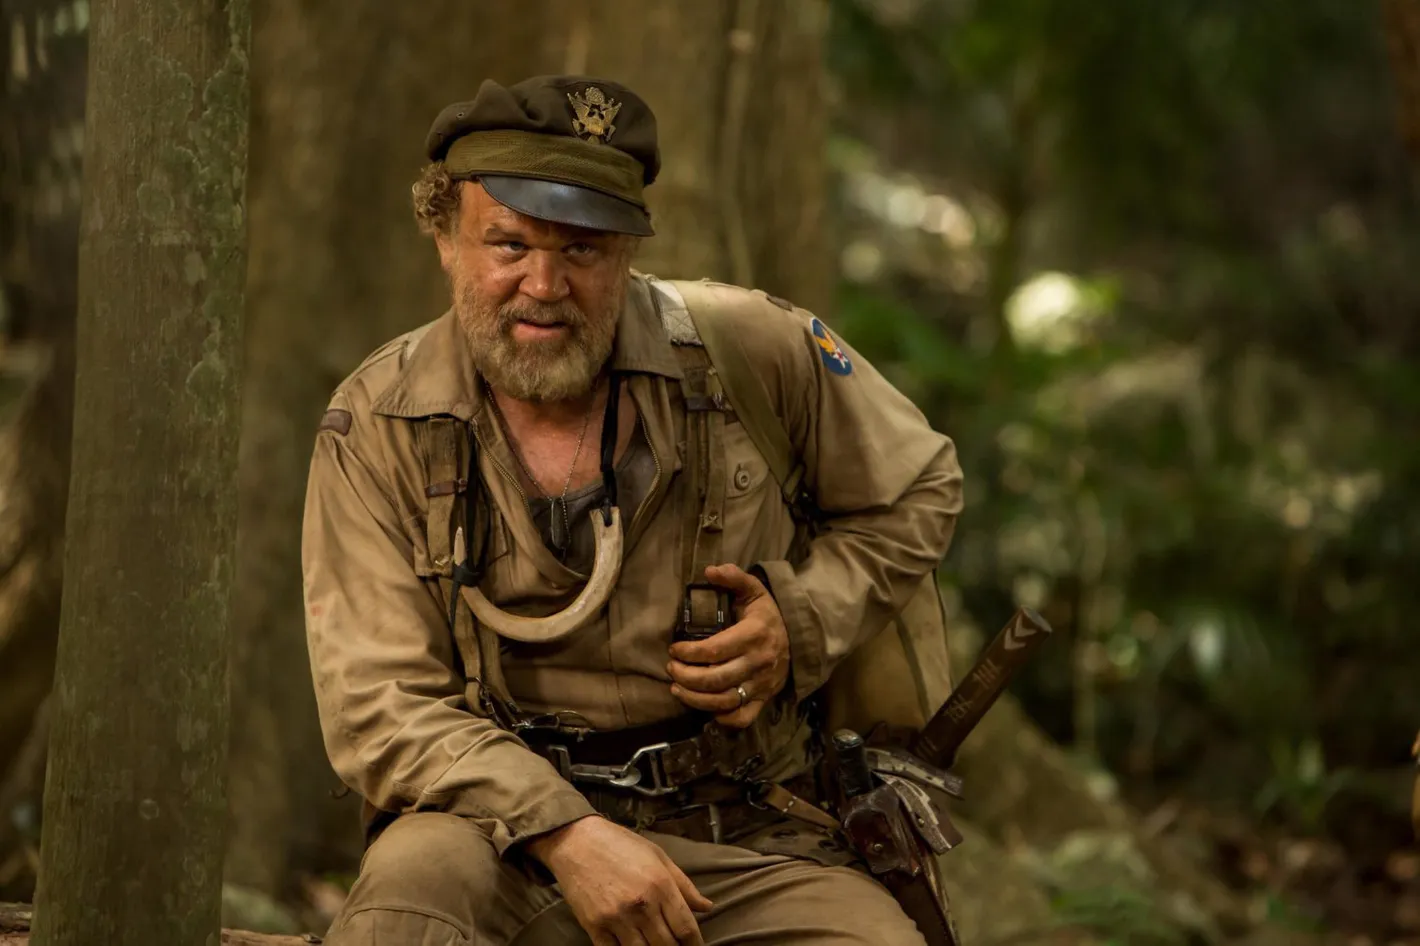Imagine the character has just encountered a mysterious artifact in the jungle. How might this change his journey? Upon discovering a mysterious artifact in the jungle, the character's journey takes a significant turn. This artifact, perhaps an ancient relic or a piece of unexplained technology, could hold secrets that pertain to his past or offer a new purpose in his life. Driven by curiosity and a sense of destiny, the character might embark on a quest to uncover the origins and significance of the artifact. This could lead him deeper into the jungle, encountering hidden tribes, ancient ruins, and unforeseen dangers. The artifact could also act as a catalyst, triggering memories or revelations that influence his decisions and interactions with others he may encounter along the way. 